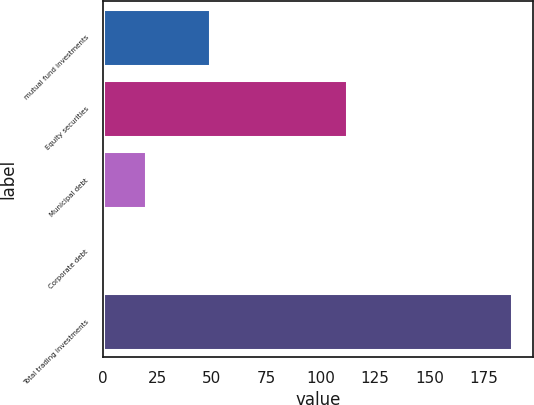Convert chart. <chart><loc_0><loc_0><loc_500><loc_500><bar_chart><fcel>mutual fund investments<fcel>Equity securities<fcel>Municipal debt<fcel>Corporate debt<fcel>Total trading investments<nl><fcel>49<fcel>112<fcel>19.7<fcel>1<fcel>188<nl></chart> 